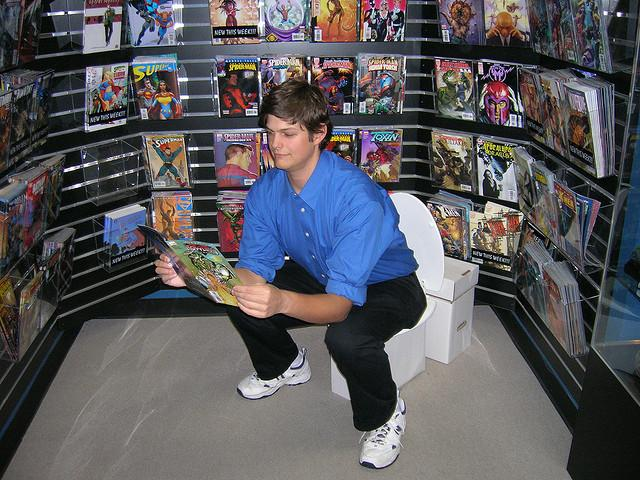What type of store is this?

Choices:
A) comic
B) grocery
C) beauty
D) store comic 